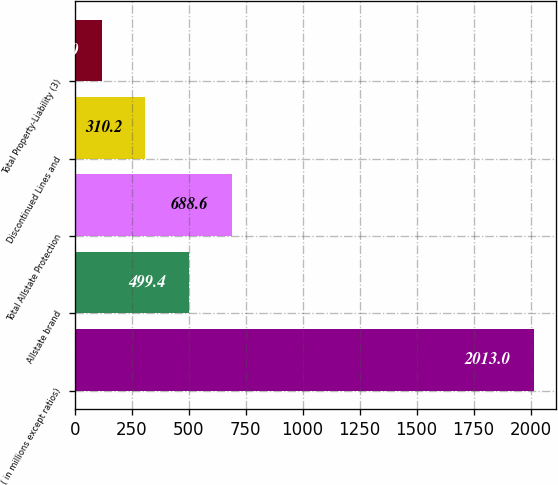<chart> <loc_0><loc_0><loc_500><loc_500><bar_chart><fcel>( in millions except ratios)<fcel>Allstate brand<fcel>Total Allstate Protection<fcel>Discontinued Lines and<fcel>Total Property-Liability (3)<nl><fcel>2013<fcel>499.4<fcel>688.6<fcel>310.2<fcel>121<nl></chart> 